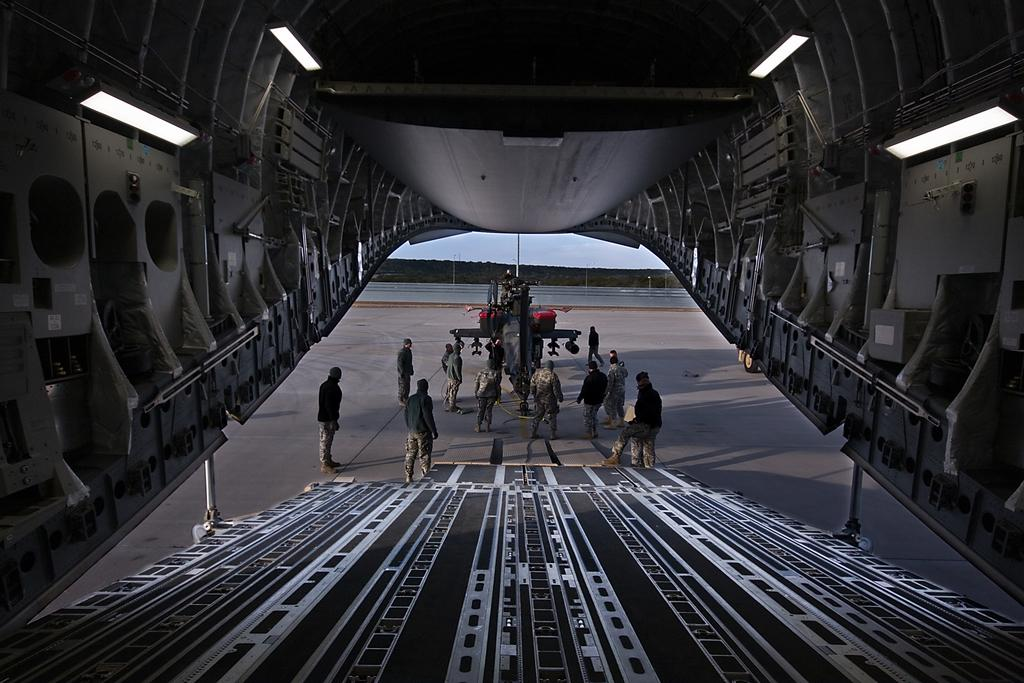What type of location is depicted in the image? The image is an inside picture of an aircraft. What can be seen in the image besides the aircraft interior? There is a ramp, people, a fighter jet, a pole, and a fence visible in the image. What is the main object in the center of the image? A fighter jet is present in the center of the image. What might be used to separate or enclose areas in the image? There is a fence in the image that could be used for separation or enclosure. What financial advice can be seen in the image? There is no financial advice present in the image. What is the interest rate of the fighter jet in the image? There is no mention of interest rates in the image, as it features a fighter jet and other objects within an aircraft interior. 